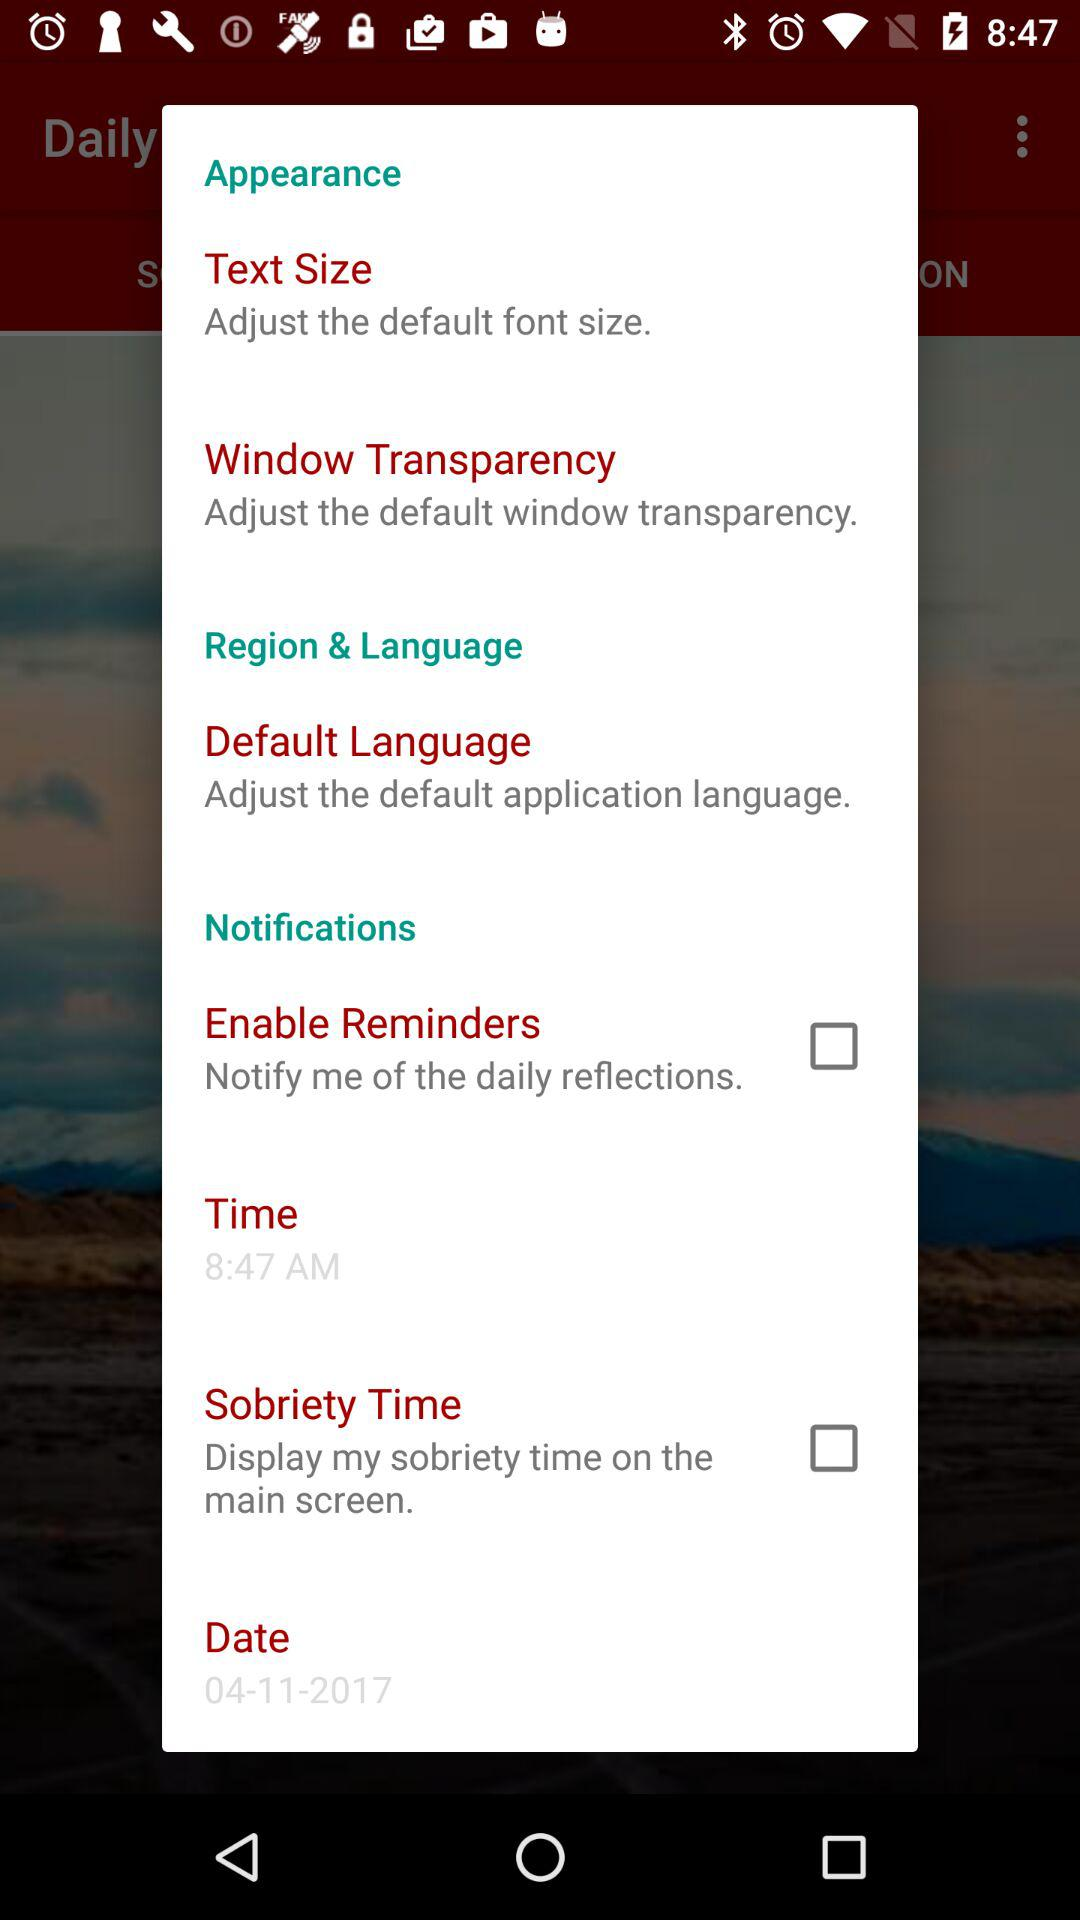What is the status of "Enable Reminders"? The status of "Enable Reminders" is "off". 